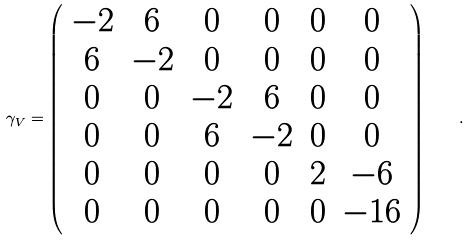Convert formula to latex. <formula><loc_0><loc_0><loc_500><loc_500>\gamma _ { V } = \left ( \begin{array} { c c c c c c } - 2 & 6 & 0 & 0 & 0 & 0 \\ 6 & - 2 & 0 & 0 & 0 & 0 \\ 0 & 0 & - 2 & 6 & 0 & 0 \\ 0 & 0 & 6 & - 2 & 0 & 0 \\ 0 & 0 & 0 & 0 & 2 & - 6 \\ 0 & 0 & 0 & 0 & 0 & - 1 6 \\ \end{array} \right ) \quad .</formula> 